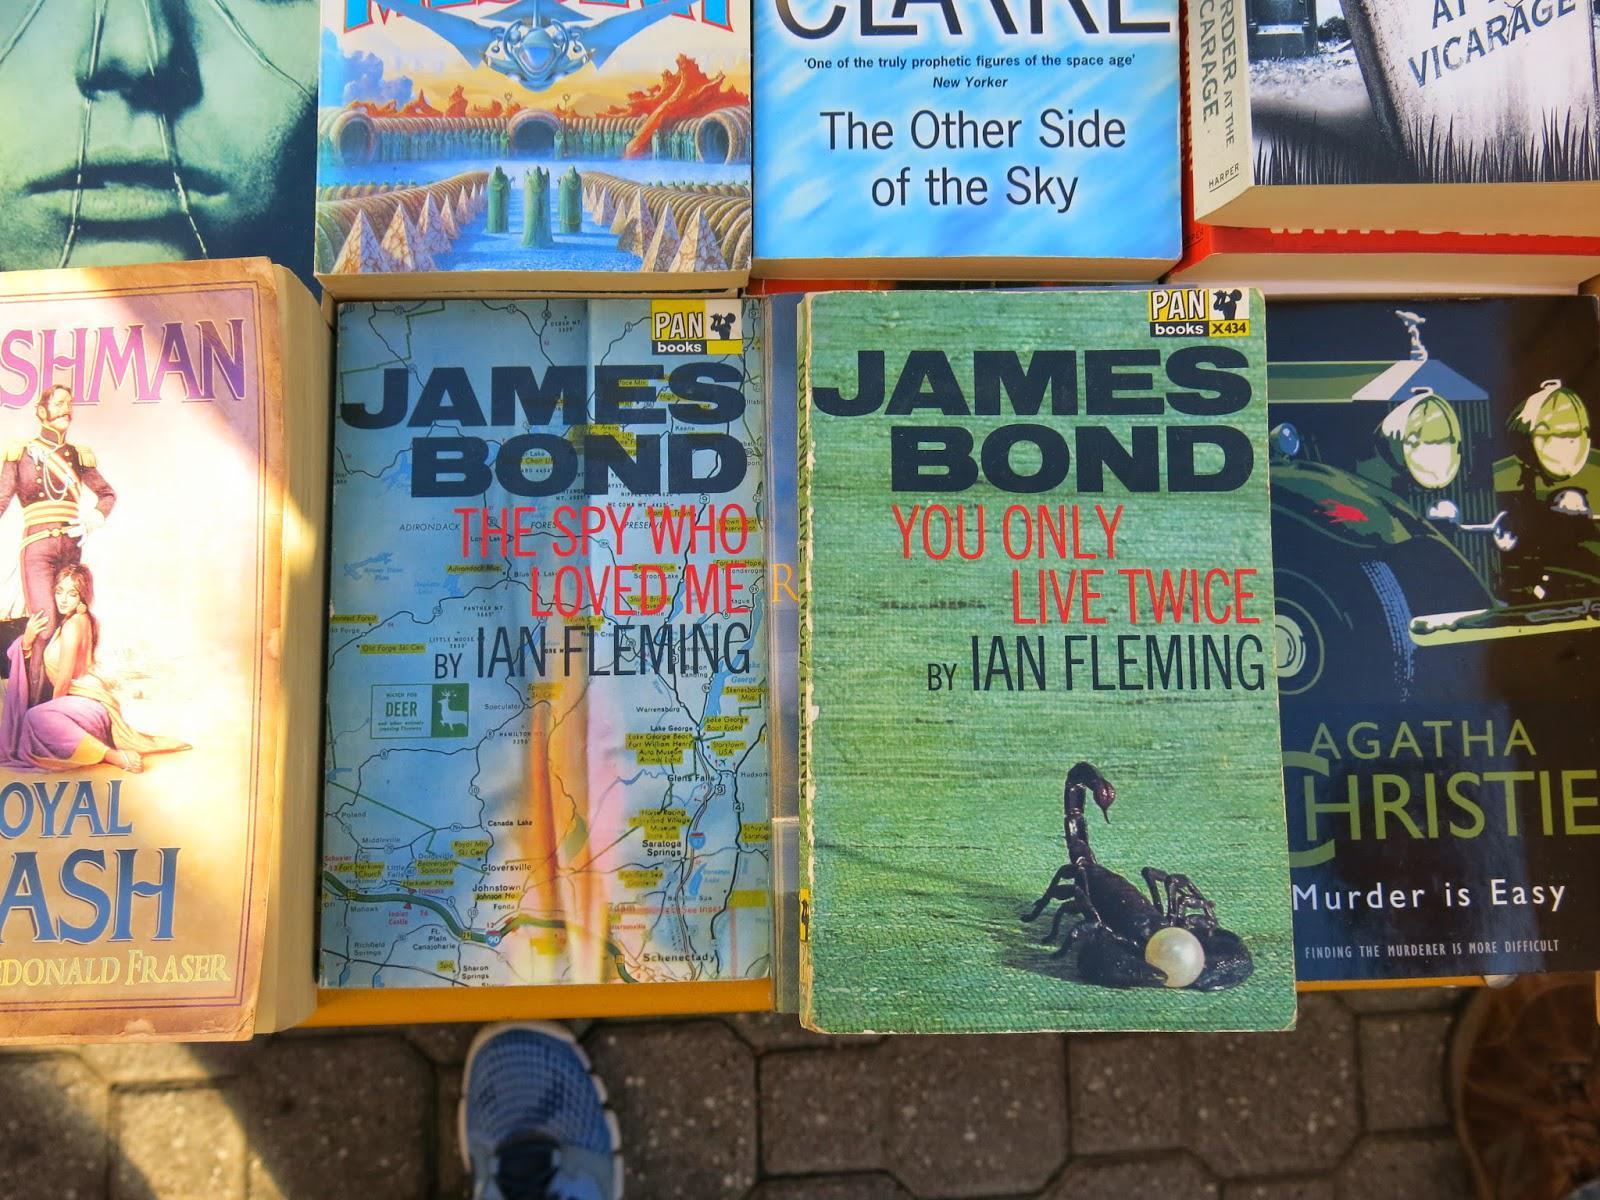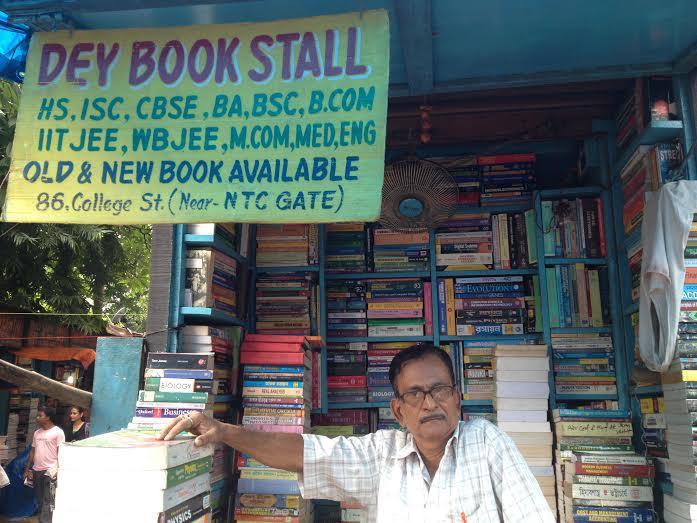The first image is the image on the left, the second image is the image on the right. Examine the images to the left and right. Is the description "One image shows a man in a light colored button up shirt sitting outside the store front next to piles of books." accurate? Answer yes or no. Yes. The first image is the image on the left, the second image is the image on the right. Evaluate the accuracy of this statement regarding the images: "There are no more than 3 people at the book store.". Is it true? Answer yes or no. Yes. 